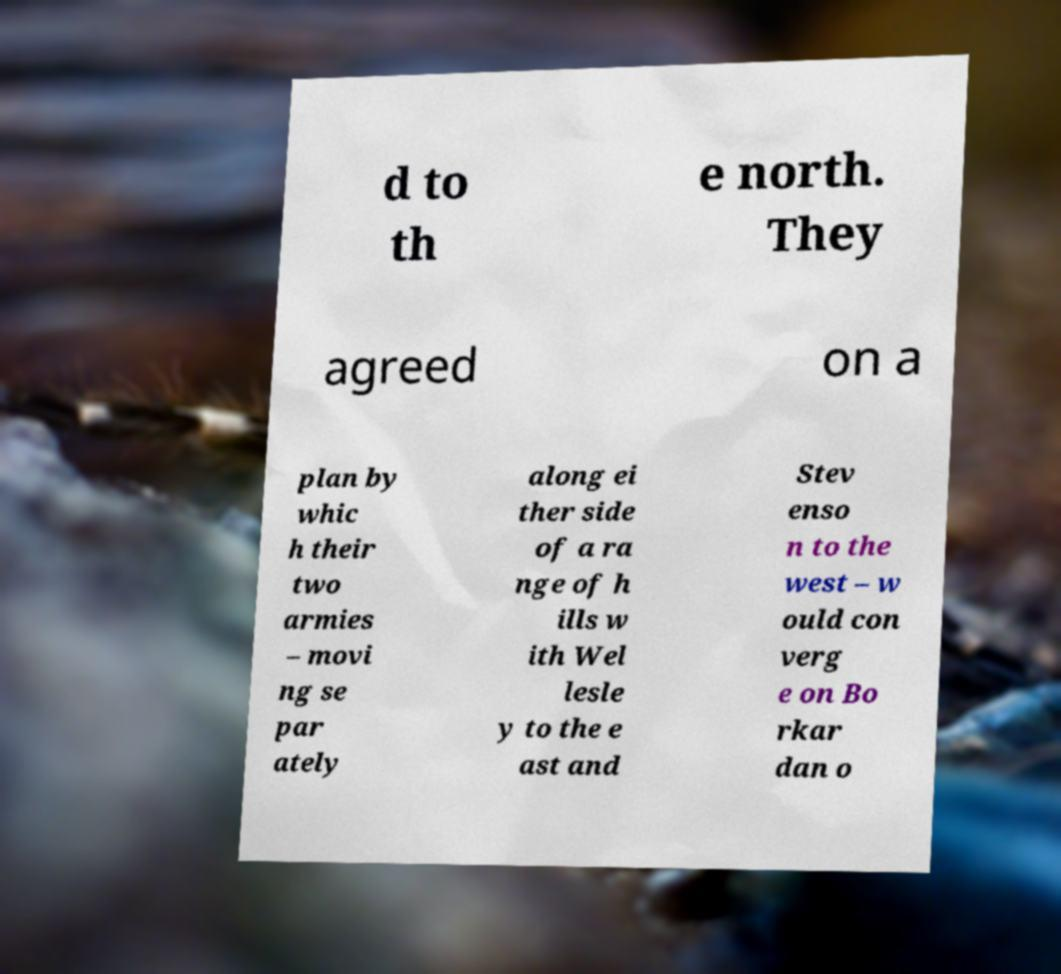What messages or text are displayed in this image? I need them in a readable, typed format. d to th e north. They agreed on a plan by whic h their two armies – movi ng se par ately along ei ther side of a ra nge of h ills w ith Wel lesle y to the e ast and Stev enso n to the west – w ould con verg e on Bo rkar dan o 